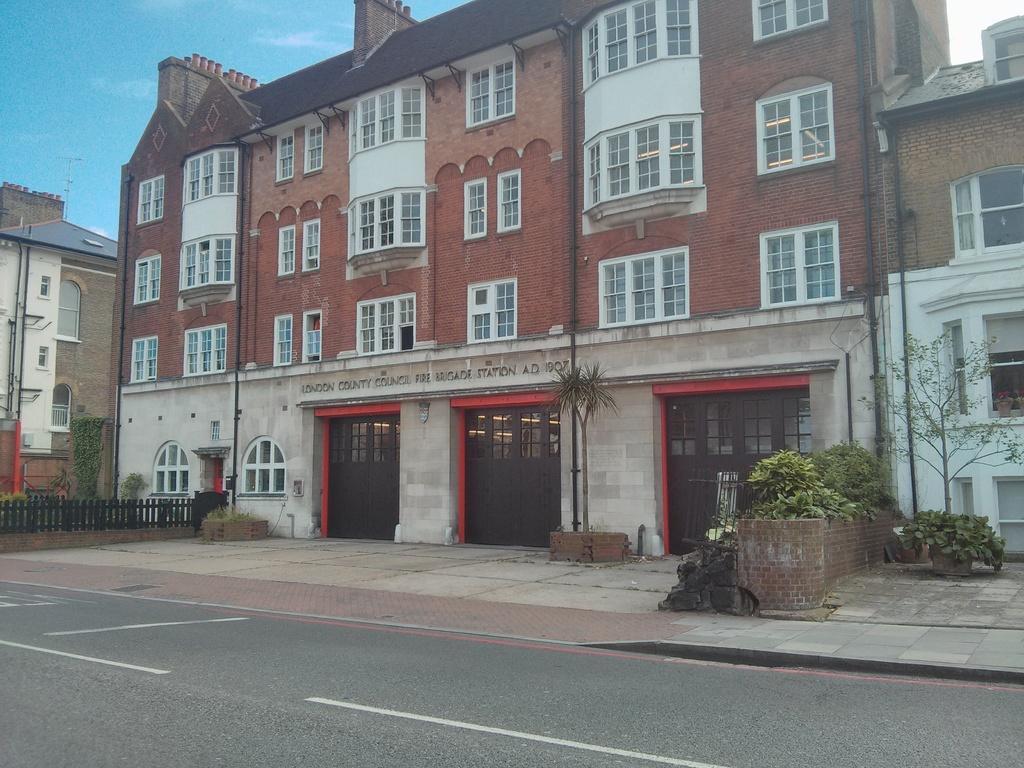Please provide a concise description of this image. In this image I can see few plants in green color, background I can see few buildings in brown, white and green color and I can also see the fencing and the sky is in blue color. 